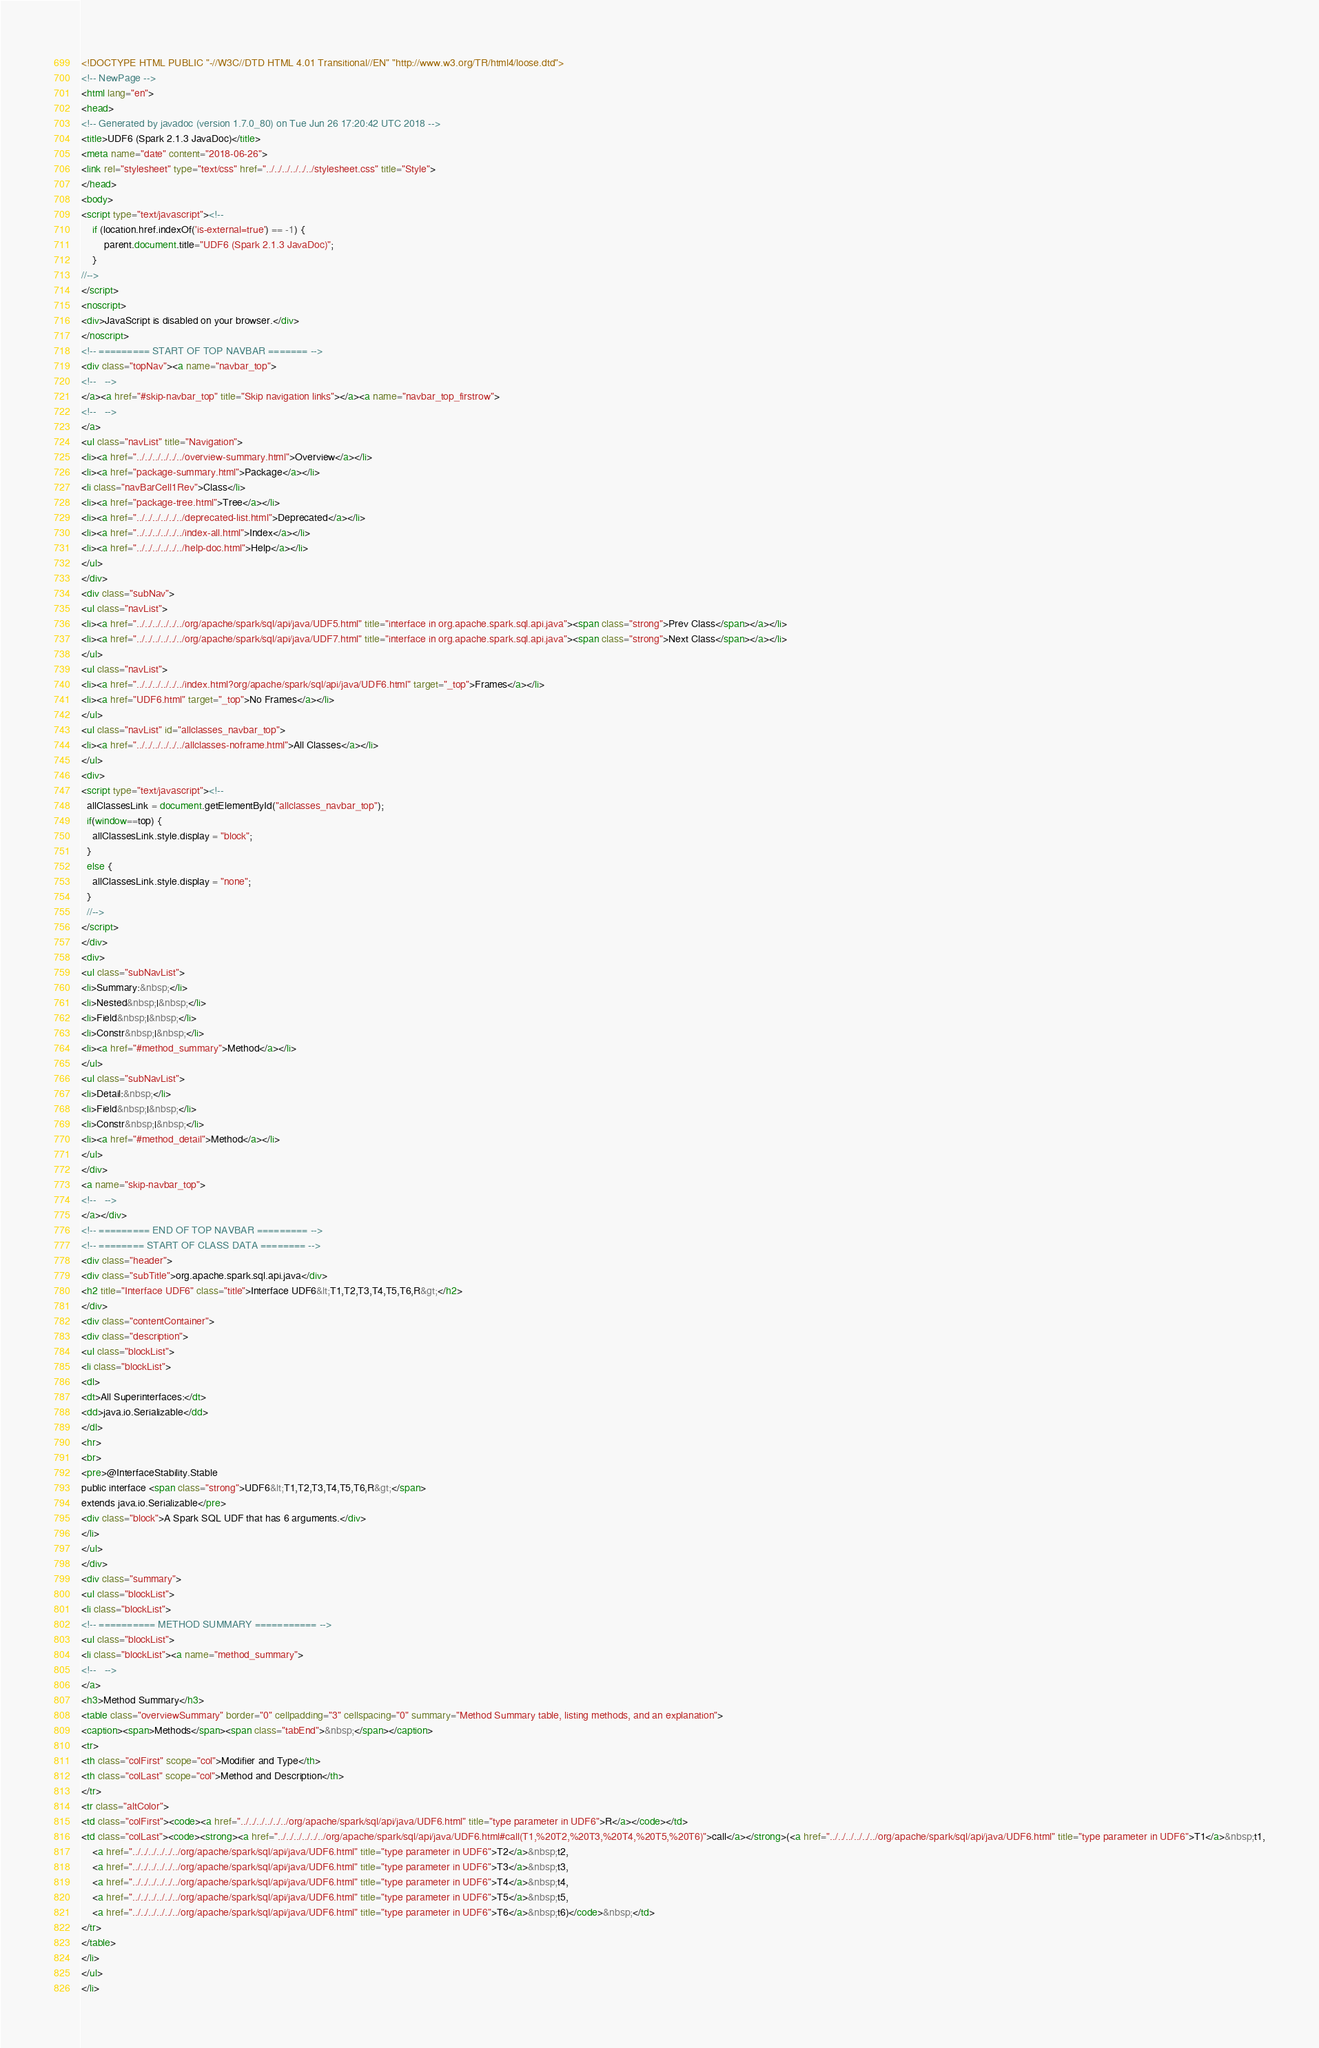Convert code to text. <code><loc_0><loc_0><loc_500><loc_500><_HTML_><!DOCTYPE HTML PUBLIC "-//W3C//DTD HTML 4.01 Transitional//EN" "http://www.w3.org/TR/html4/loose.dtd">
<!-- NewPage -->
<html lang="en">
<head>
<!-- Generated by javadoc (version 1.7.0_80) on Tue Jun 26 17:20:42 UTC 2018 -->
<title>UDF6 (Spark 2.1.3 JavaDoc)</title>
<meta name="date" content="2018-06-26">
<link rel="stylesheet" type="text/css" href="../../../../../../stylesheet.css" title="Style">
</head>
<body>
<script type="text/javascript"><!--
    if (location.href.indexOf('is-external=true') == -1) {
        parent.document.title="UDF6 (Spark 2.1.3 JavaDoc)";
    }
//-->
</script>
<noscript>
<div>JavaScript is disabled on your browser.</div>
</noscript>
<!-- ========= START OF TOP NAVBAR ======= -->
<div class="topNav"><a name="navbar_top">
<!--   -->
</a><a href="#skip-navbar_top" title="Skip navigation links"></a><a name="navbar_top_firstrow">
<!--   -->
</a>
<ul class="navList" title="Navigation">
<li><a href="../../../../../../overview-summary.html">Overview</a></li>
<li><a href="package-summary.html">Package</a></li>
<li class="navBarCell1Rev">Class</li>
<li><a href="package-tree.html">Tree</a></li>
<li><a href="../../../../../../deprecated-list.html">Deprecated</a></li>
<li><a href="../../../../../../index-all.html">Index</a></li>
<li><a href="../../../../../../help-doc.html">Help</a></li>
</ul>
</div>
<div class="subNav">
<ul class="navList">
<li><a href="../../../../../../org/apache/spark/sql/api/java/UDF5.html" title="interface in org.apache.spark.sql.api.java"><span class="strong">Prev Class</span></a></li>
<li><a href="../../../../../../org/apache/spark/sql/api/java/UDF7.html" title="interface in org.apache.spark.sql.api.java"><span class="strong">Next Class</span></a></li>
</ul>
<ul class="navList">
<li><a href="../../../../../../index.html?org/apache/spark/sql/api/java/UDF6.html" target="_top">Frames</a></li>
<li><a href="UDF6.html" target="_top">No Frames</a></li>
</ul>
<ul class="navList" id="allclasses_navbar_top">
<li><a href="../../../../../../allclasses-noframe.html">All Classes</a></li>
</ul>
<div>
<script type="text/javascript"><!--
  allClassesLink = document.getElementById("allclasses_navbar_top");
  if(window==top) {
    allClassesLink.style.display = "block";
  }
  else {
    allClassesLink.style.display = "none";
  }
  //-->
</script>
</div>
<div>
<ul class="subNavList">
<li>Summary:&nbsp;</li>
<li>Nested&nbsp;|&nbsp;</li>
<li>Field&nbsp;|&nbsp;</li>
<li>Constr&nbsp;|&nbsp;</li>
<li><a href="#method_summary">Method</a></li>
</ul>
<ul class="subNavList">
<li>Detail:&nbsp;</li>
<li>Field&nbsp;|&nbsp;</li>
<li>Constr&nbsp;|&nbsp;</li>
<li><a href="#method_detail">Method</a></li>
</ul>
</div>
<a name="skip-navbar_top">
<!--   -->
</a></div>
<!-- ========= END OF TOP NAVBAR ========= -->
<!-- ======== START OF CLASS DATA ======== -->
<div class="header">
<div class="subTitle">org.apache.spark.sql.api.java</div>
<h2 title="Interface UDF6" class="title">Interface UDF6&lt;T1,T2,T3,T4,T5,T6,R&gt;</h2>
</div>
<div class="contentContainer">
<div class="description">
<ul class="blockList">
<li class="blockList">
<dl>
<dt>All Superinterfaces:</dt>
<dd>java.io.Serializable</dd>
</dl>
<hr>
<br>
<pre>@InterfaceStability.Stable
public interface <span class="strong">UDF6&lt;T1,T2,T3,T4,T5,T6,R&gt;</span>
extends java.io.Serializable</pre>
<div class="block">A Spark SQL UDF that has 6 arguments.</div>
</li>
</ul>
</div>
<div class="summary">
<ul class="blockList">
<li class="blockList">
<!-- ========== METHOD SUMMARY =========== -->
<ul class="blockList">
<li class="blockList"><a name="method_summary">
<!--   -->
</a>
<h3>Method Summary</h3>
<table class="overviewSummary" border="0" cellpadding="3" cellspacing="0" summary="Method Summary table, listing methods, and an explanation">
<caption><span>Methods</span><span class="tabEnd">&nbsp;</span></caption>
<tr>
<th class="colFirst" scope="col">Modifier and Type</th>
<th class="colLast" scope="col">Method and Description</th>
</tr>
<tr class="altColor">
<td class="colFirst"><code><a href="../../../../../../org/apache/spark/sql/api/java/UDF6.html" title="type parameter in UDF6">R</a></code></td>
<td class="colLast"><code><strong><a href="../../../../../../org/apache/spark/sql/api/java/UDF6.html#call(T1,%20T2,%20T3,%20T4,%20T5,%20T6)">call</a></strong>(<a href="../../../../../../org/apache/spark/sql/api/java/UDF6.html" title="type parameter in UDF6">T1</a>&nbsp;t1,
    <a href="../../../../../../org/apache/spark/sql/api/java/UDF6.html" title="type parameter in UDF6">T2</a>&nbsp;t2,
    <a href="../../../../../../org/apache/spark/sql/api/java/UDF6.html" title="type parameter in UDF6">T3</a>&nbsp;t3,
    <a href="../../../../../../org/apache/spark/sql/api/java/UDF6.html" title="type parameter in UDF6">T4</a>&nbsp;t4,
    <a href="../../../../../../org/apache/spark/sql/api/java/UDF6.html" title="type parameter in UDF6">T5</a>&nbsp;t5,
    <a href="../../../../../../org/apache/spark/sql/api/java/UDF6.html" title="type parameter in UDF6">T6</a>&nbsp;t6)</code>&nbsp;</td>
</tr>
</table>
</li>
</ul>
</li></code> 